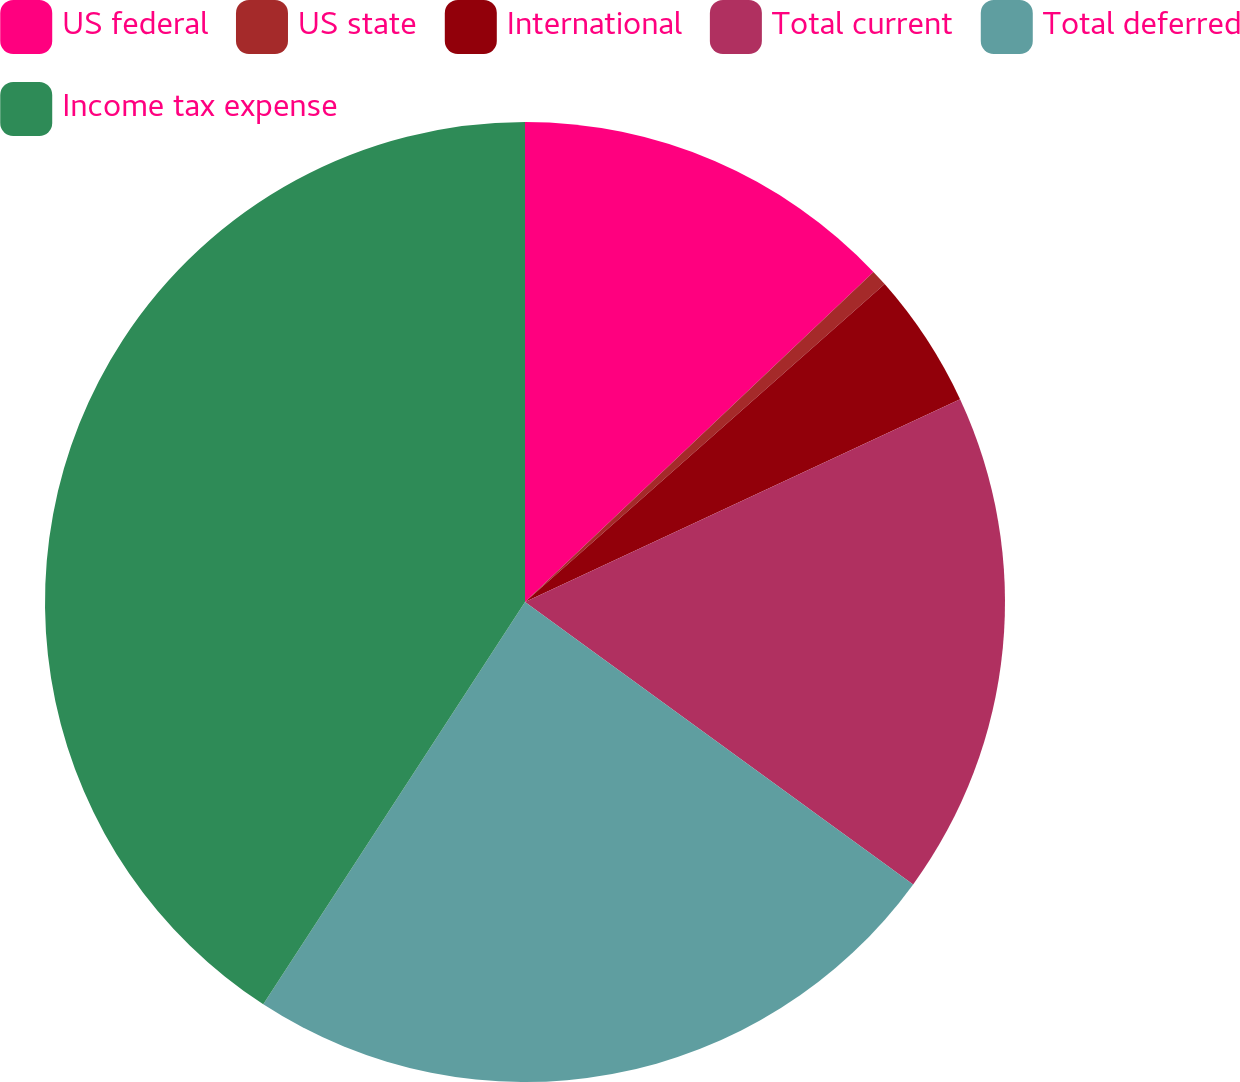<chart> <loc_0><loc_0><loc_500><loc_500><pie_chart><fcel>US federal<fcel>US state<fcel>International<fcel>Total current<fcel>Total deferred<fcel>Income tax expense<nl><fcel>12.93%<fcel>0.55%<fcel>4.58%<fcel>16.95%<fcel>24.17%<fcel>40.82%<nl></chart> 